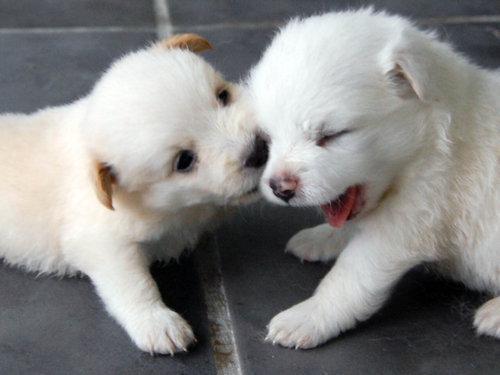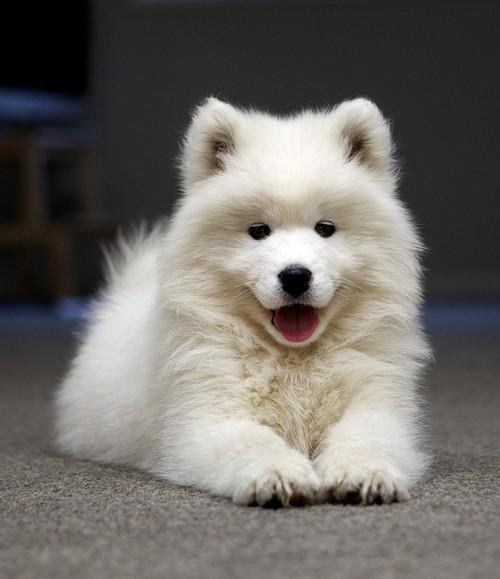The first image is the image on the left, the second image is the image on the right. Considering the images on both sides, is "One image contains twice as many white puppies as the other image and features puppies with their heads touching." valid? Answer yes or no. Yes. The first image is the image on the left, the second image is the image on the right. For the images displayed, is the sentence "There are at most two dogs." factually correct? Answer yes or no. No. 